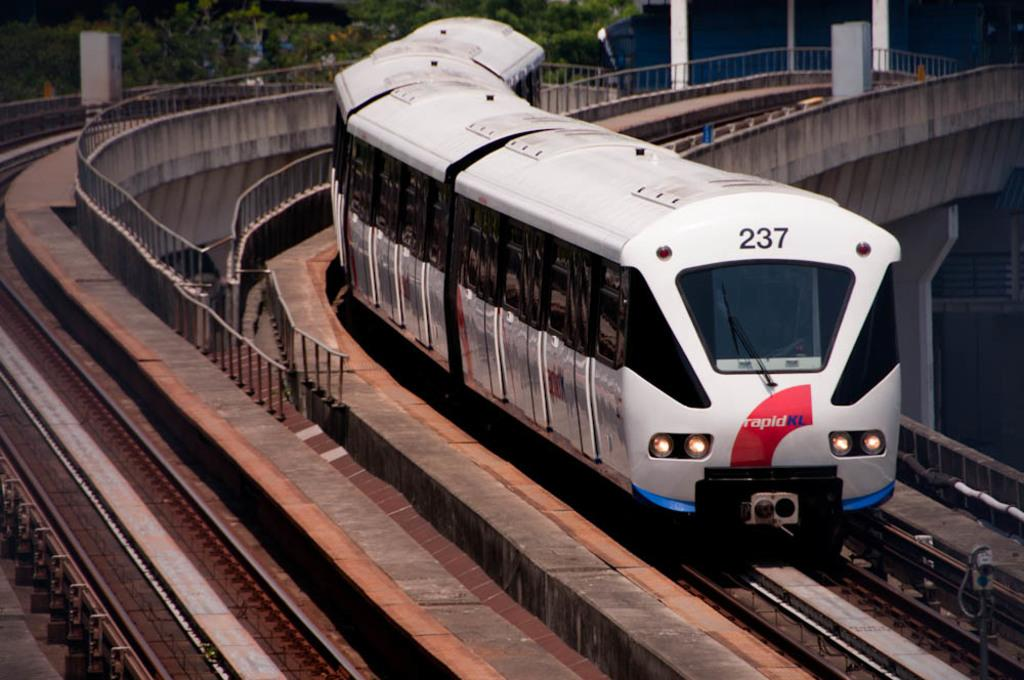<image>
Give a short and clear explanation of the subsequent image. A train going down a track on an overpass with the number 237 in the front top of the train. 